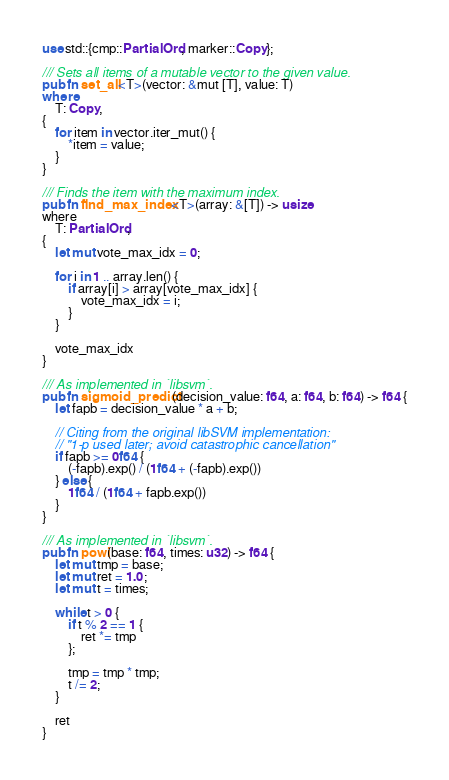Convert code to text. <code><loc_0><loc_0><loc_500><loc_500><_Rust_>use std::{cmp::PartialOrd, marker::Copy};

/// Sets all items of a mutable vector to the given value.
pub fn set_all<T>(vector: &mut [T], value: T)
where
    T: Copy,
{
    for item in vector.iter_mut() {
        *item = value;
    }
}

/// Finds the item with the maximum index.
pub fn find_max_index<T>(array: &[T]) -> usize
where
    T: PartialOrd,
{
    let mut vote_max_idx = 0;

    for i in 1 .. array.len() {
        if array[i] > array[vote_max_idx] {
            vote_max_idx = i;
        }
    }

    vote_max_idx
}

/// As implemented in `libsvm`.
pub fn sigmoid_predict(decision_value: f64, a: f64, b: f64) -> f64 {
    let fapb = decision_value * a + b;

    // Citing from the original libSVM implementation:
    // "1-p used later; avoid catastrophic cancellation"
    if fapb >= 0f64 {
        (-fapb).exp() / (1f64 + (-fapb).exp())
    } else {
        1f64 / (1f64 + fapb.exp())
    }
}

/// As implemented in `libsvm`.
pub fn powi(base: f64, times: u32) -> f64 {
    let mut tmp = base;
    let mut ret = 1.0;
    let mut t = times;

    while t > 0 {
        if t % 2 == 1 {
            ret *= tmp
        };

        tmp = tmp * tmp;
        t /= 2;
    }

    ret
}
</code> 